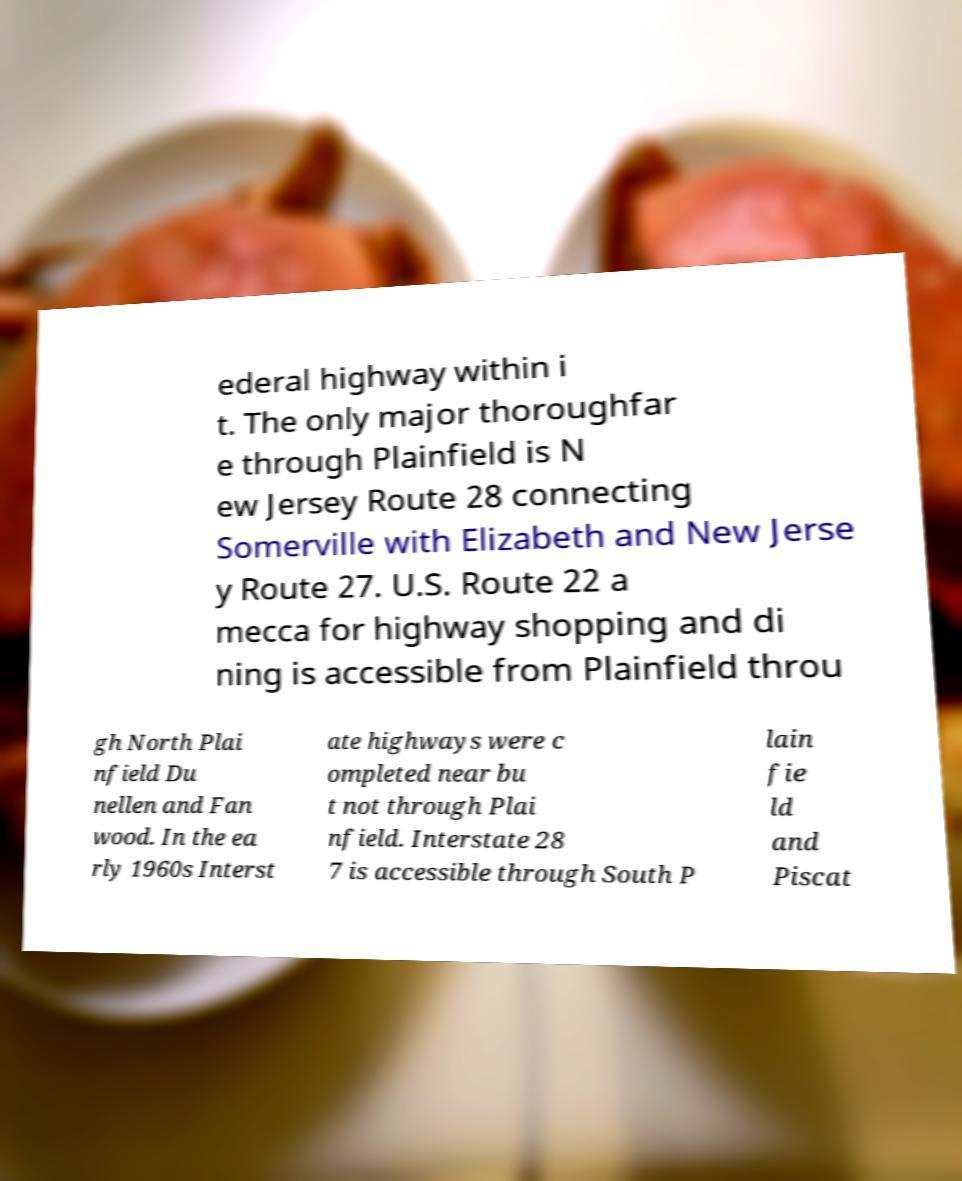For documentation purposes, I need the text within this image transcribed. Could you provide that? ederal highway within i t. The only major thoroughfar e through Plainfield is N ew Jersey Route 28 connecting Somerville with Elizabeth and New Jerse y Route 27. U.S. Route 22 a mecca for highway shopping and di ning is accessible from Plainfield throu gh North Plai nfield Du nellen and Fan wood. In the ea rly 1960s Interst ate highways were c ompleted near bu t not through Plai nfield. Interstate 28 7 is accessible through South P lain fie ld and Piscat 